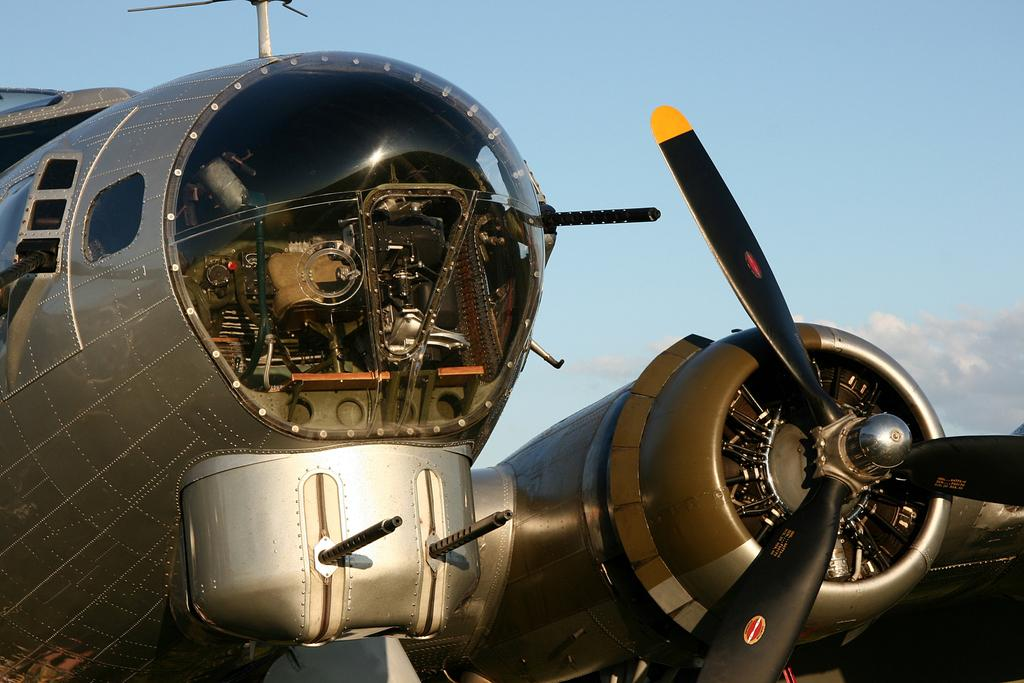What is the main subject of the picture? The main subject of the picture is an airplane. What object can be seen on the right side of the picture? There is a spinner on the right side of the picture. What is visible in the background of the picture? The sky is visible in the background of the picture. What type of creature can be seen with fangs in the picture? There is no creature with fangs present in the picture; it features an airplane and a spinner. How many trains are visible in the picture? There are no trains visible in the picture; it only contains an airplane and a spinner. 